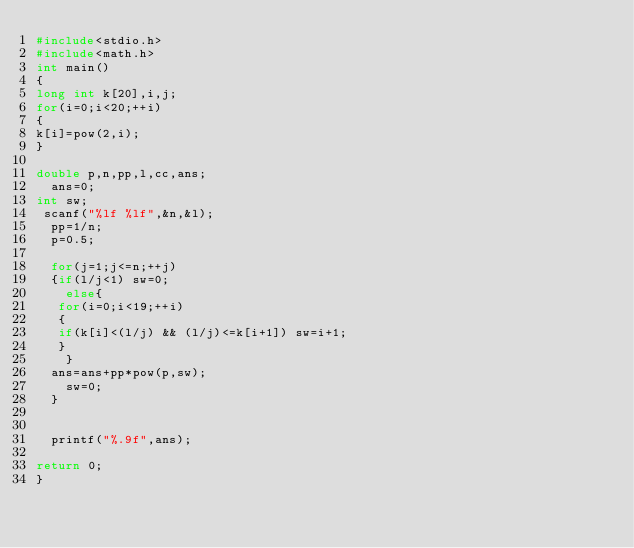<code> <loc_0><loc_0><loc_500><loc_500><_C_>#include<stdio.h>
#include<math.h>
int main()
{
long int k[20],i,j;
for(i=0;i<20;++i)
{
k[i]=pow(2,i);  
} 
  
double p,n,pp,l,cc,ans;
  ans=0;
int sw;
 scanf("%lf %lf",&n,&l);
  pp=1/n;
  p=0.5;
  
  for(j=1;j<=n;++j)
  {if(l/j<1) sw=0;
    else{
   for(i=0;i<19;++i)
   {
   if(k[i]<(l/j) && (l/j)<=k[i+1]) sw=i+1;
   }
    }
  ans=ans+pp*pow(p,sw);
    sw=0;
  }
  
  
  printf("%.9f",ans);

return 0;
}</code> 